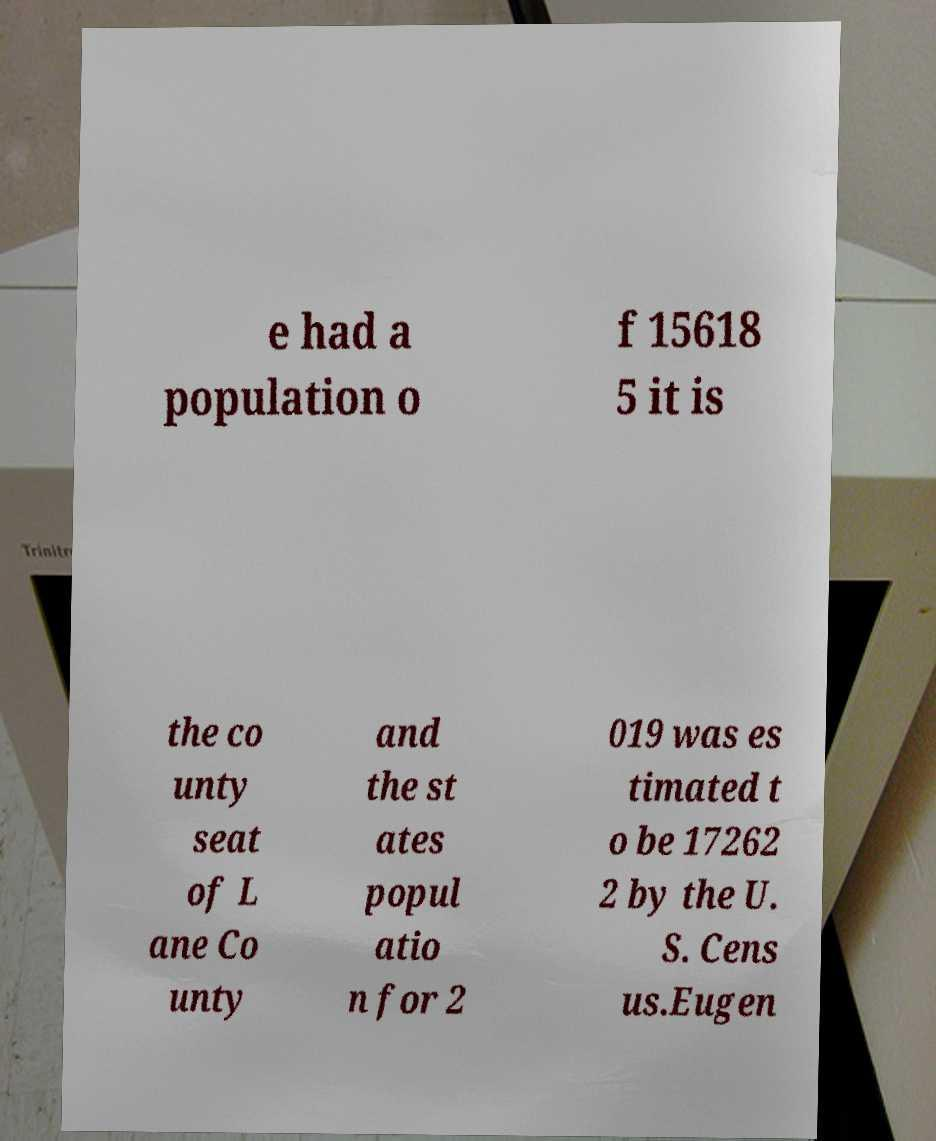Please read and relay the text visible in this image. What does it say? e had a population o f 15618 5 it is the co unty seat of L ane Co unty and the st ates popul atio n for 2 019 was es timated t o be 17262 2 by the U. S. Cens us.Eugen 